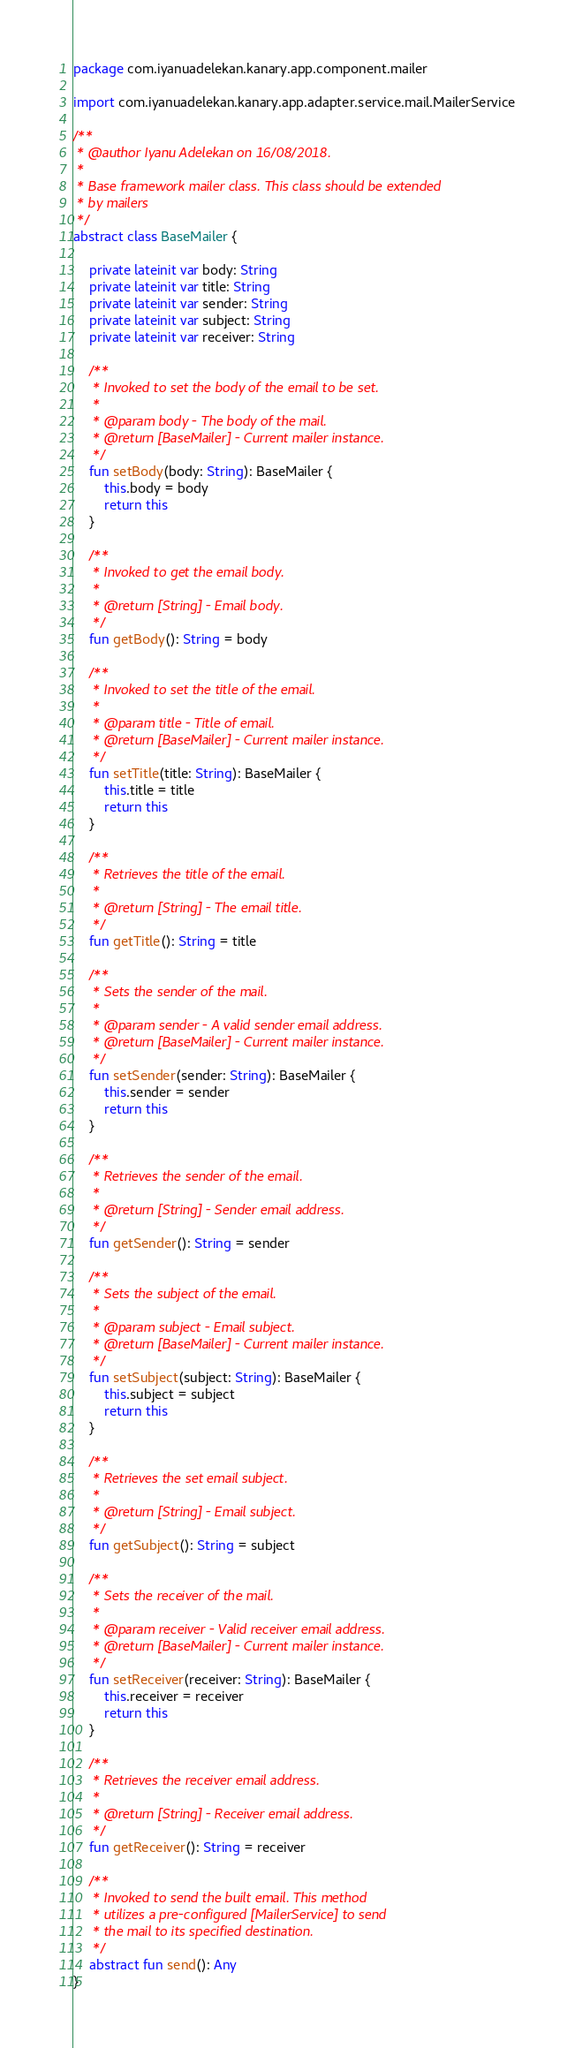<code> <loc_0><loc_0><loc_500><loc_500><_Kotlin_>package com.iyanuadelekan.kanary.app.component.mailer

import com.iyanuadelekan.kanary.app.adapter.service.mail.MailerService

/**
 * @author Iyanu Adelekan on 16/08/2018.
 *
 * Base framework mailer class. This class should be extended
 * by mailers
 */
abstract class BaseMailer {

    private lateinit var body: String
    private lateinit var title: String
    private lateinit var sender: String
    private lateinit var subject: String
    private lateinit var receiver: String

    /**
     * Invoked to set the body of the email to be set.
     *
     * @param body - The body of the mail.
     * @return [BaseMailer] - Current mailer instance.
     */
    fun setBody(body: String): BaseMailer {
        this.body = body
        return this
    }

    /**
     * Invoked to get the email body.
     *
     * @return [String] - Email body.
     */
    fun getBody(): String = body

    /**
     * Invoked to set the title of the email.
     *
     * @param title - Title of email.
     * @return [BaseMailer] - Current mailer instance.
     */
    fun setTitle(title: String): BaseMailer {
        this.title = title
        return this
    }

    /**
     * Retrieves the title of the email.
     *
     * @return [String] - The email title.
     */
    fun getTitle(): String = title

    /**
     * Sets the sender of the mail.
     *
     * @param sender - A valid sender email address.
     * @return [BaseMailer] - Current mailer instance.
     */
    fun setSender(sender: String): BaseMailer {
        this.sender = sender
        return this
    }

    /**
     * Retrieves the sender of the email.
     *
     * @return [String] - Sender email address.
     */
    fun getSender(): String = sender

    /**
     * Sets the subject of the email.
     *
     * @param subject - Email subject.
     * @return [BaseMailer] - Current mailer instance.
     */
    fun setSubject(subject: String): BaseMailer {
        this.subject = subject
        return this
    }

    /**
     * Retrieves the set email subject.
     *
     * @return [String] - Email subject.
     */
    fun getSubject(): String = subject

    /**
     * Sets the receiver of the mail.
     *
     * @param receiver - Valid receiver email address.
     * @return [BaseMailer] - Current mailer instance.
     */
    fun setReceiver(receiver: String): BaseMailer {
        this.receiver = receiver
        return this
    }

    /**
     * Retrieves the receiver email address.
     *
     * @return [String] - Receiver email address.
     */
    fun getReceiver(): String = receiver

    /**
     * Invoked to send the built email. This method
     * utilizes a pre-configured [MailerService] to send
     * the mail to its specified destination.
     */
    abstract fun send(): Any
}</code> 